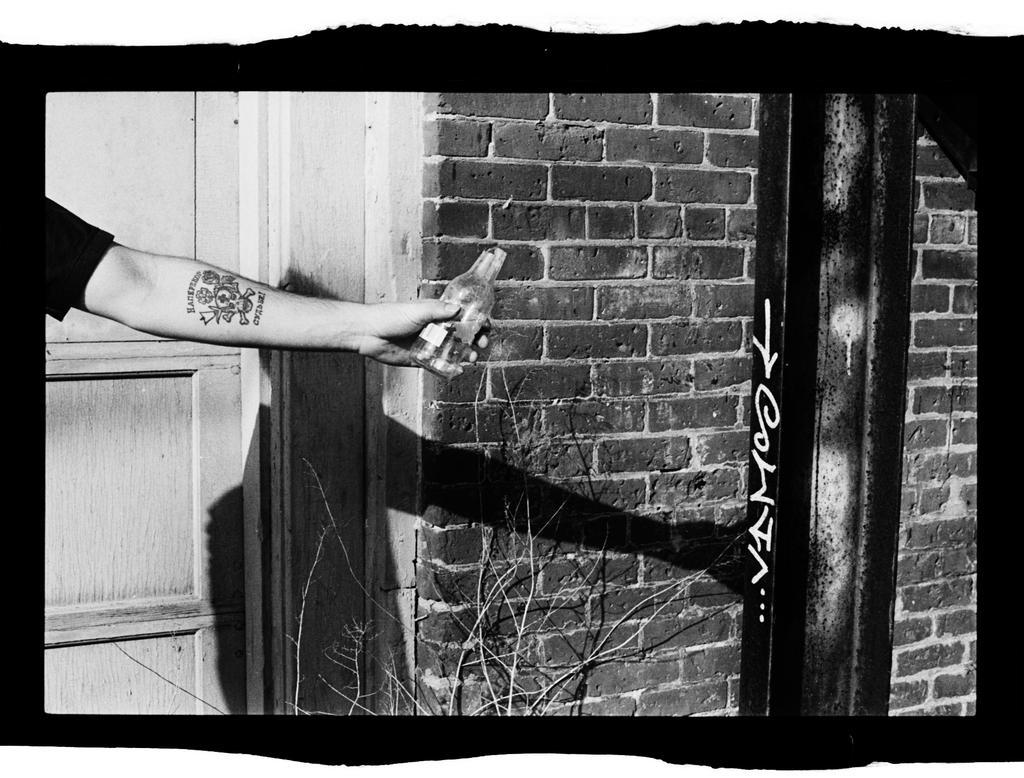In one or two sentences, can you explain what this image depicts? This is edited, black and white image. I can see a pole and the wall. On the left side of the image, there is a wooden door and a person's hand holding a bottle. At the bottom of the image, I can see stems. 